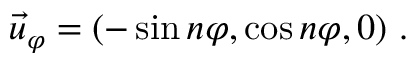<formula> <loc_0><loc_0><loc_500><loc_500>\vec { u } _ { \varphi } = ( - \sin n \varphi , \cos n \varphi , 0 ) \ .</formula> 